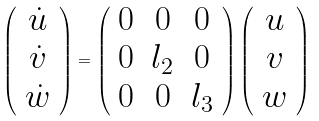<formula> <loc_0><loc_0><loc_500><loc_500>\left ( \begin{array} { c } \dot { u } \\ \dot { v } \\ \dot { w } \end{array} \right ) = \left ( \begin{array} { c c c } 0 & 0 & 0 \\ 0 & l _ { 2 } & 0 \\ 0 & 0 & l _ { 3 } \end{array} \right ) \left ( \begin{array} { c } u \\ v \\ w \end{array} \right )</formula> 